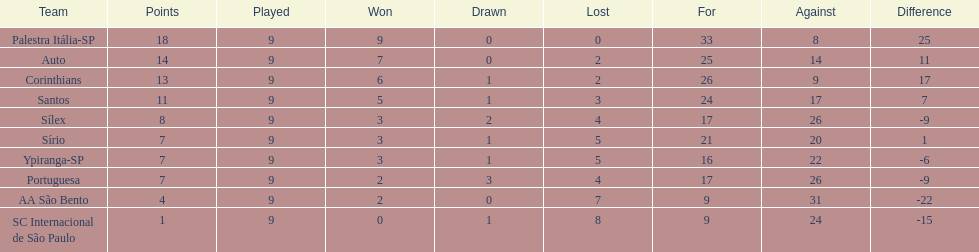In 1926 brazilian football, how many teams scored above 10 points in the season? 4. 